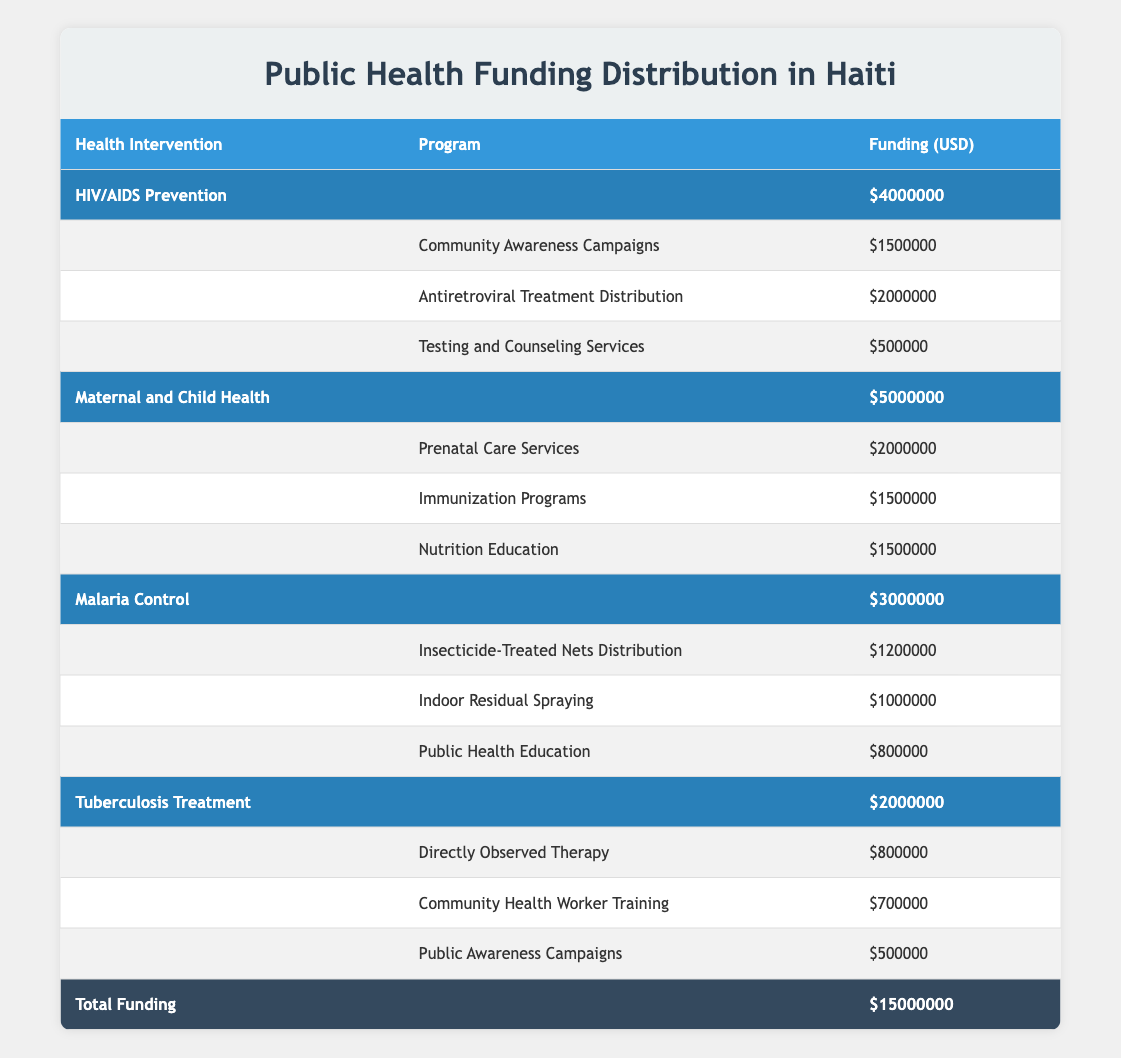What is the total funding allocated for Maternal and Child Health? The total funding for Maternal and Child Health can be found in the table, specifically in the Budget column under that intervention, which shows a total of 5000000.
Answer: 5000000 How much funding is designated for Community Awareness Campaigns? The funding for Community Awareness Campaigns is listed in the Programs section under the HIV/AIDS Prevention intervention, showing a specific amount of 1500000 in the Funding column.
Answer: 1500000 Which health intervention has the highest budget? To find the intervention with the highest budget, we can compare the Budget column for each intervention: HIV/AIDS Prevention (4000000), Maternal and Child Health (5000000), Malaria Control (3000000), and Tuberculosis Treatment (2000000). Maternal and Child Health has the highest budget of 5000000.
Answer: Maternal and Child Health Is the funding for Indoor Residual Spraying greater than that for Public Awareness Campaigns? We can compare the two funding amounts: Indoor Residual Spraying has a funding of 1000000, while Public Awareness Campaigns has 500000. Since 1000000 is greater than 500000, the statement is true.
Answer: Yes What is the total funding for HIV/AIDS Prevention programs? To calculate the total funding for HIV/AIDS Prevention programs, we add the funding amounts for each program: Community Awareness Campaigns (1500000) + Antiretroviral Treatment Distribution (2000000) + Testing and Counseling Services (500000) = 4000000. This matches the overall budget for that intervention, confirming our calculation is correct.
Answer: 4000000 What percentage of the total funding is allocated to Tuberculosis Treatment? The percentage can be calculated by dividing the Tuberculosis Treatment budget (2000000) by the total funding (15000000) and then multiplying by 100 to find the percentage. (2000000 / 15000000) * 100 = 13.33%.
Answer: 13.33% Does Maternal and Child Health funding exceed the total funding for Malaria Control and Tuberculosis Treatment combined? We can find the total funding for Malaria Control (3000000) and Tuberculosis Treatment (2000000) and add them together: 3000000 + 2000000 = 5000000. Maternal and Child Health also has a funding of 5000000, hence the two values are equal.
Answer: No What is the total funding for all health interventions combined? The total funding for the health interventions is displayed at the bottom of the table as Total Funding, which sums up all the individual budgets: 15000000.
Answer: 15000000 